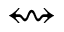Convert formula to latex. <formula><loc_0><loc_0><loc_500><loc_500>\left r i g h t s q u i g a r r o w</formula> 